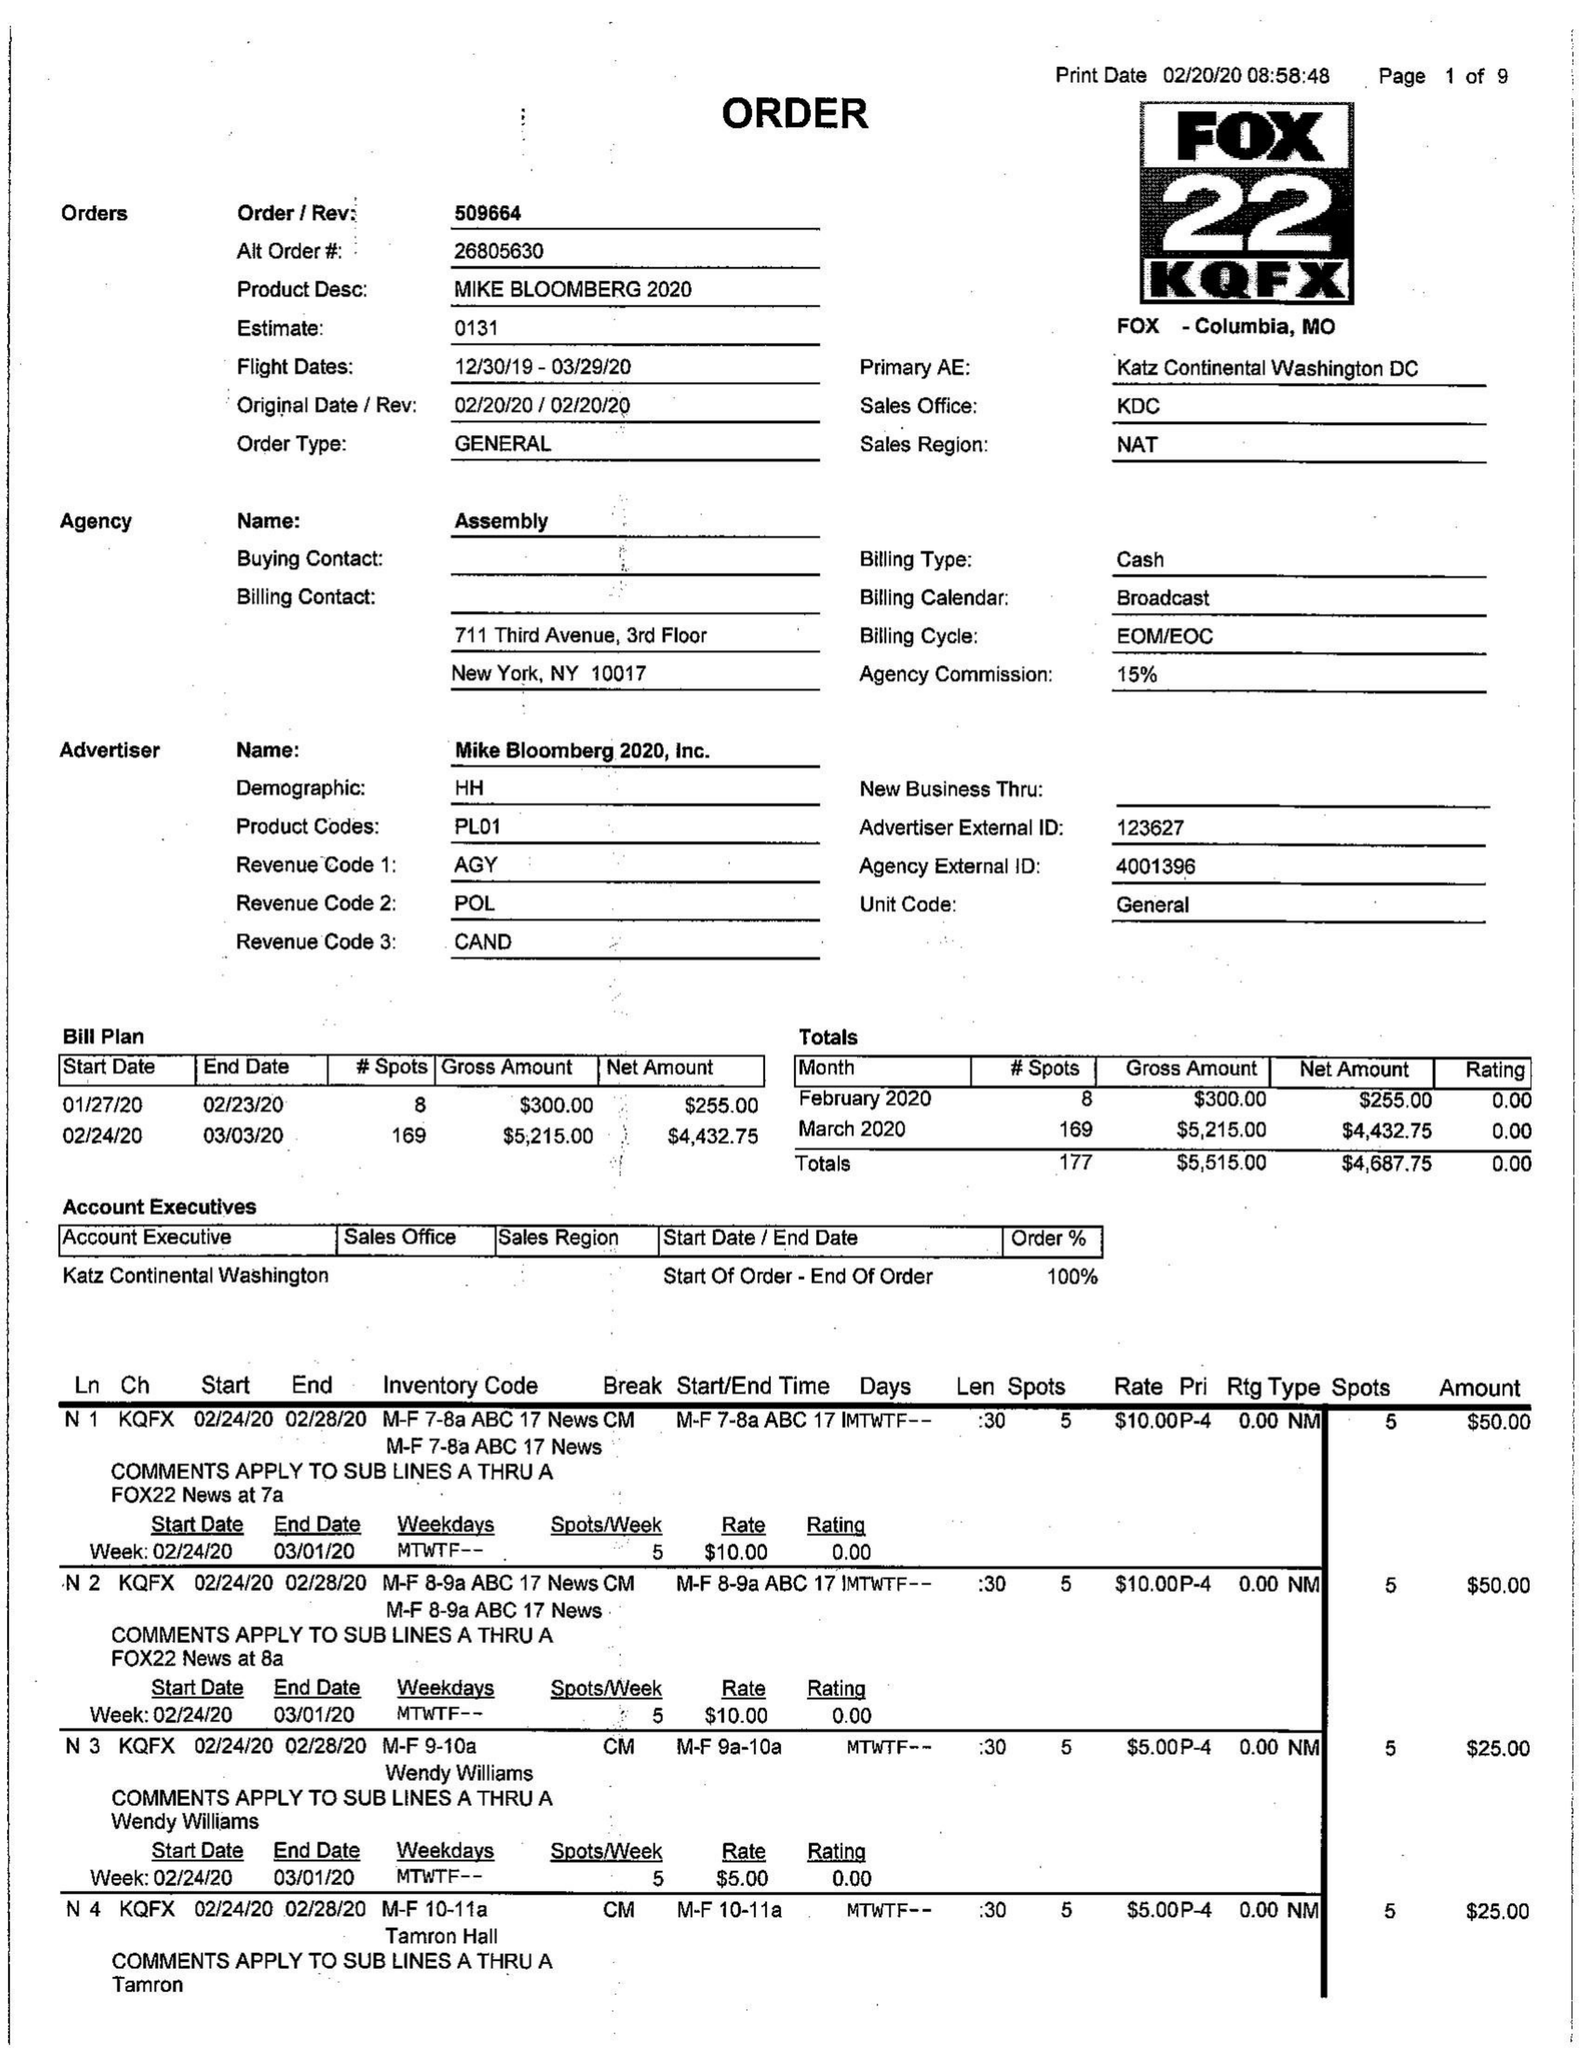What is the value for the advertiser?
Answer the question using a single word or phrase. MIKE BLOOMBERG 2020, INC. 